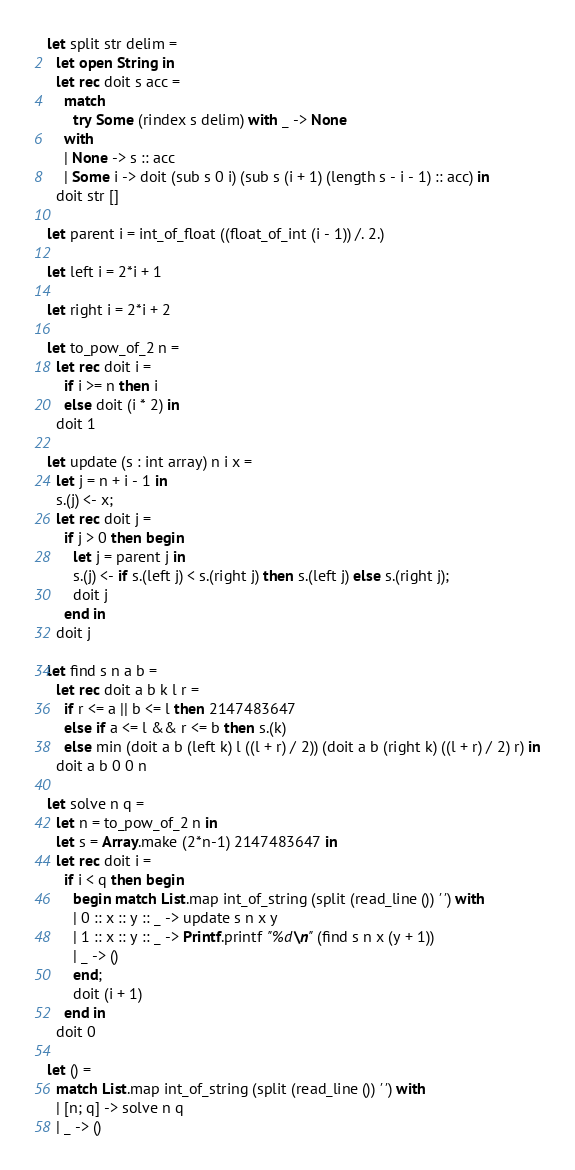<code> <loc_0><loc_0><loc_500><loc_500><_OCaml_>let split str delim =
  let open String in
  let rec doit s acc =
    match
      try Some (rindex s delim) with _ -> None
    with
    | None -> s :: acc
    | Some i -> doit (sub s 0 i) (sub s (i + 1) (length s - i - 1) :: acc) in
  doit str []

let parent i = int_of_float ((float_of_int (i - 1)) /. 2.)

let left i = 2*i + 1

let right i = 2*i + 2

let to_pow_of_2 n =
  let rec doit i =
    if i >= n then i
    else doit (i * 2) in
  doit 1

let update (s : int array) n i x =
  let j = n + i - 1 in
  s.(j) <- x;
  let rec doit j =
    if j > 0 then begin
      let j = parent j in
      s.(j) <- if s.(left j) < s.(right j) then s.(left j) else s.(right j);
      doit j
    end in
  doit j

let find s n a b =
  let rec doit a b k l r =
    if r <= a || b <= l then 2147483647
    else if a <= l && r <= b then s.(k)
    else min (doit a b (left k) l ((l + r) / 2)) (doit a b (right k) ((l + r) / 2) r) in
  doit a b 0 0 n

let solve n q =
  let n = to_pow_of_2 n in
  let s = Array.make (2*n-1) 2147483647 in
  let rec doit i =
    if i < q then begin
      begin match List.map int_of_string (split (read_line ()) ' ') with
      | 0 :: x :: y :: _ -> update s n x y
      | 1 :: x :: y :: _ -> Printf.printf "%d\n" (find s n x (y + 1))
      | _ -> ()
      end;
      doit (i + 1)
    end in
  doit 0

let () =
  match List.map int_of_string (split (read_line ()) ' ') with
  | [n; q] -> solve n q
  | _ -> ()</code> 